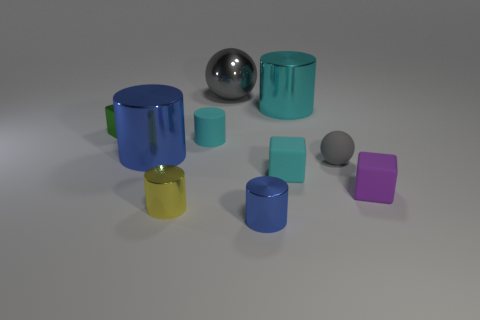What might be the purpose of arranging these objects in such a way? The arrangement of these objects might serve various educational or aesthetic purposes. It could be a setup for a visual exercise in a geometry class, illustrating different 3D shapes and their properties. Alternatively, it might be an artistic composition, emphasizing color, form, and the play of light on different surfaces to create a visually appealing image.  How does the lighting affect the appearance of the objects? The lighting in the image appears to be soft and diffused, casting subtle shadows and gently highlighting the contours of each object. It accentuates the textures and material qualities, such as the matte finish of the cylinders and the reflective sheen of the sphere. The lighting contributes to the overall mood of the scene, which is calm and understated, allowing the shapes and colors of the objects to stand out. 